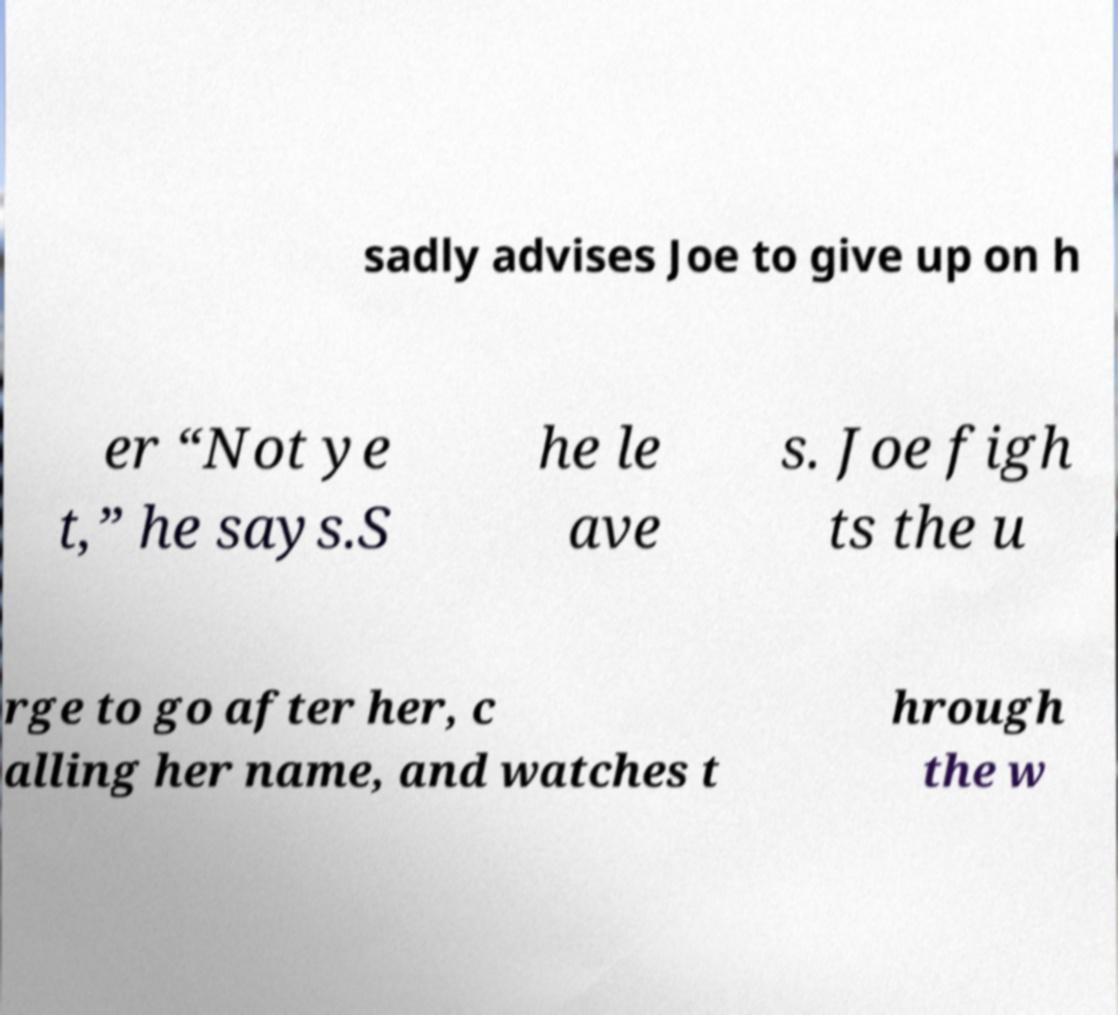Please read and relay the text visible in this image. What does it say? sadly advises Joe to give up on h er “Not ye t,” he says.S he le ave s. Joe figh ts the u rge to go after her, c alling her name, and watches t hrough the w 